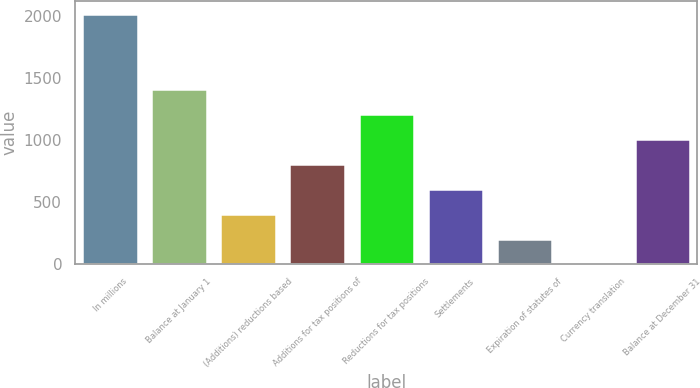<chart> <loc_0><loc_0><loc_500><loc_500><bar_chart><fcel>In millions<fcel>Balance at January 1<fcel>(Additions) reductions based<fcel>Additions for tax positions of<fcel>Reductions for tax positions<fcel>Settlements<fcel>Expiration of statutes of<fcel>Currency translation<fcel>Balance at December 31<nl><fcel>2013<fcel>1409.4<fcel>403.4<fcel>805.8<fcel>1208.2<fcel>604.6<fcel>202.2<fcel>1<fcel>1007<nl></chart> 